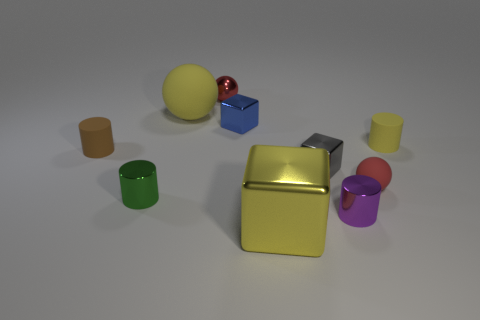Subtract all brown cylinders. How many red balls are left? 2 Subtract all yellow cubes. How many cubes are left? 2 Subtract 1 blocks. How many blocks are left? 2 Subtract all brown cylinders. How many cylinders are left? 3 Subtract all cyan cylinders. Subtract all cyan cubes. How many cylinders are left? 4 Subtract all cylinders. How many objects are left? 6 Subtract 0 purple balls. How many objects are left? 10 Subtract all purple metal cylinders. Subtract all tiny red metal balls. How many objects are left? 8 Add 4 red objects. How many red objects are left? 6 Add 2 purple objects. How many purple objects exist? 3 